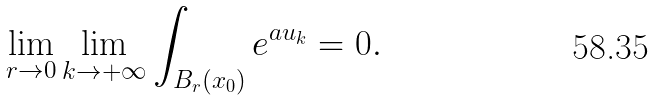<formula> <loc_0><loc_0><loc_500><loc_500>\lim _ { r \to 0 } \lim _ { k \to + \infty } \int _ { B _ { r } ( x _ { 0 } ) } e ^ { a u _ { k } } = 0 .</formula> 